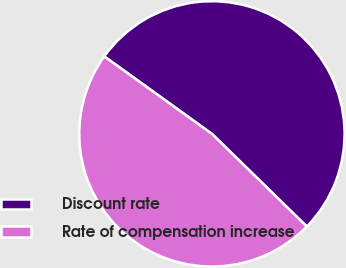Convert chart to OTSL. <chart><loc_0><loc_0><loc_500><loc_500><pie_chart><fcel>Discount rate<fcel>Rate of compensation increase<nl><fcel>52.38%<fcel>47.62%<nl></chart> 